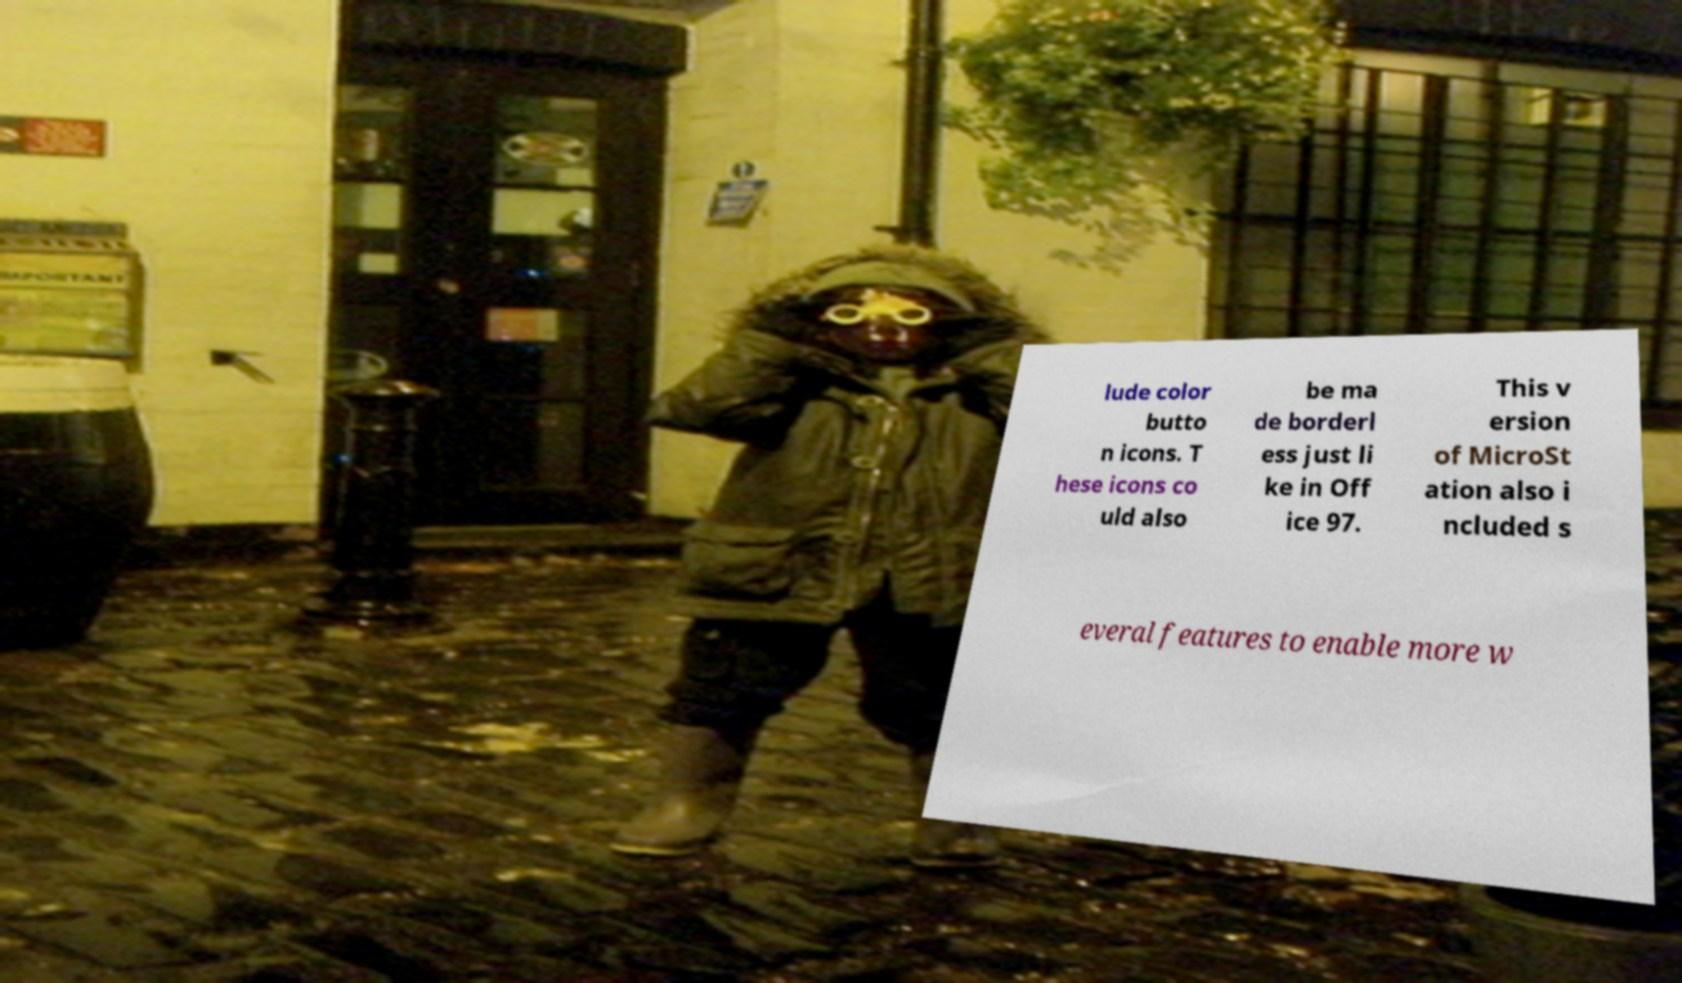Could you assist in decoding the text presented in this image and type it out clearly? lude color butto n icons. T hese icons co uld also be ma de borderl ess just li ke in Off ice 97. This v ersion of MicroSt ation also i ncluded s everal features to enable more w 